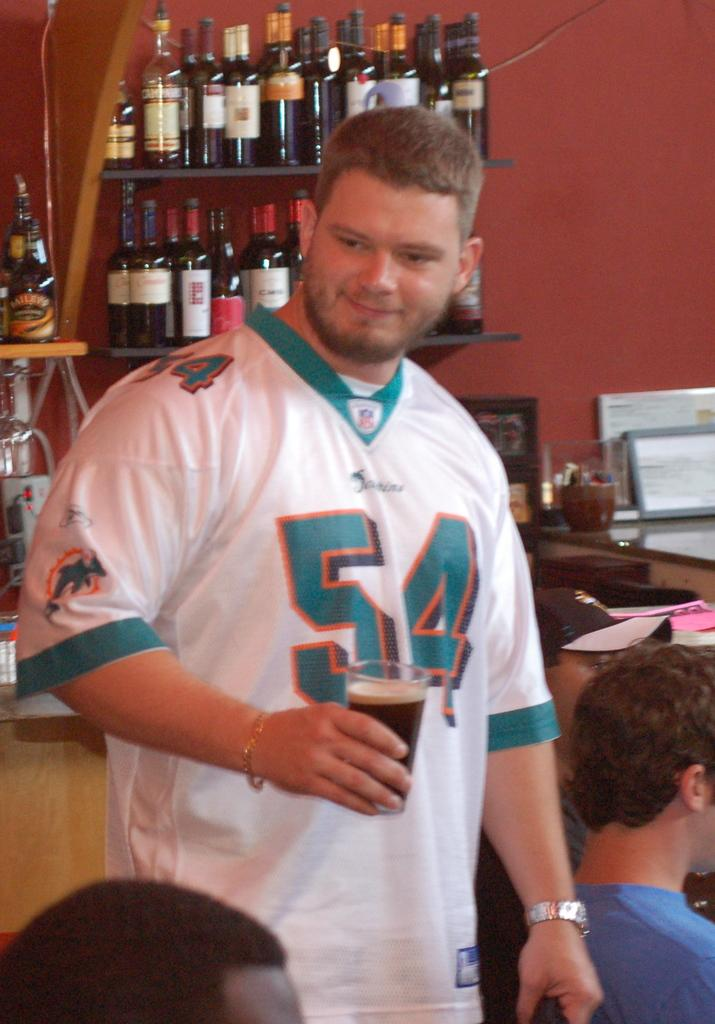Provide a one-sentence caption for the provided image. a man in 54 jersey smiles at someone down below. 